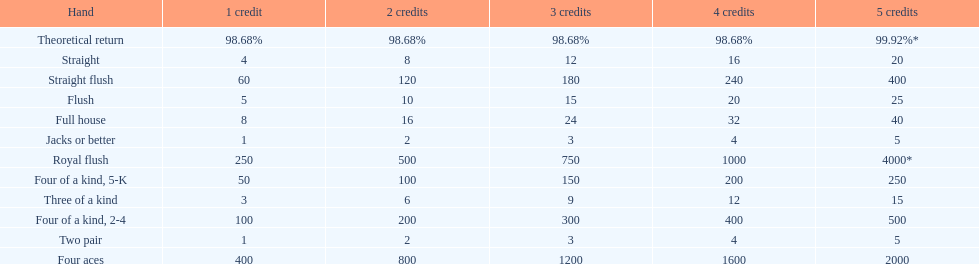Parse the full table. {'header': ['Hand', '1 credit', '2 credits', '3 credits', '4 credits', '5 credits'], 'rows': [['Theoretical return', '98.68%', '98.68%', '98.68%', '98.68%', '99.92%*'], ['Straight', '4', '8', '12', '16', '20'], ['Straight flush', '60', '120', '180', '240', '400'], ['Flush', '5', '10', '15', '20', '25'], ['Full house', '8', '16', '24', '32', '40'], ['Jacks or better', '1', '2', '3', '4', '5'], ['Royal flush', '250', '500', '750', '1000', '4000*'], ['Four of a kind, 5-K', '50', '100', '150', '200', '250'], ['Three of a kind', '3', '6', '9', '12', '15'], ['Four of a kind, 2-4', '100', '200', '300', '400', '500'], ['Two pair', '1', '2', '3', '4', '5'], ['Four aces', '400', '800', '1200', '1600', '2000']]} The number of credits returned for a one credit bet on a royal flush are. 250. 